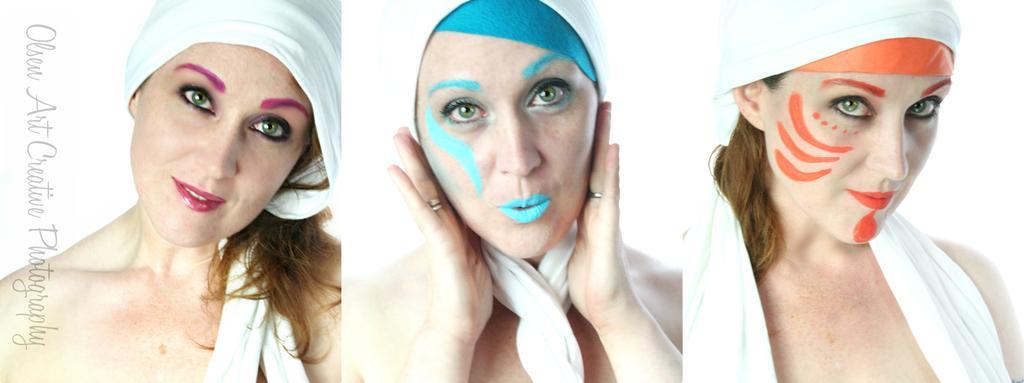Can you describe this image briefly? In the image a woman is standing and smiling and it is a collage picture. 